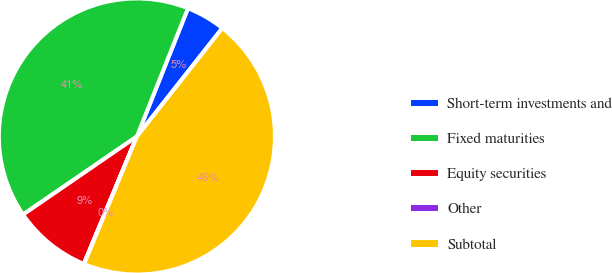Convert chart. <chart><loc_0><loc_0><loc_500><loc_500><pie_chart><fcel>Short-term investments and<fcel>Fixed maturities<fcel>Equity securities<fcel>Other<fcel>Subtotal<nl><fcel>4.59%<fcel>40.6%<fcel>9.15%<fcel>0.03%<fcel>45.62%<nl></chart> 